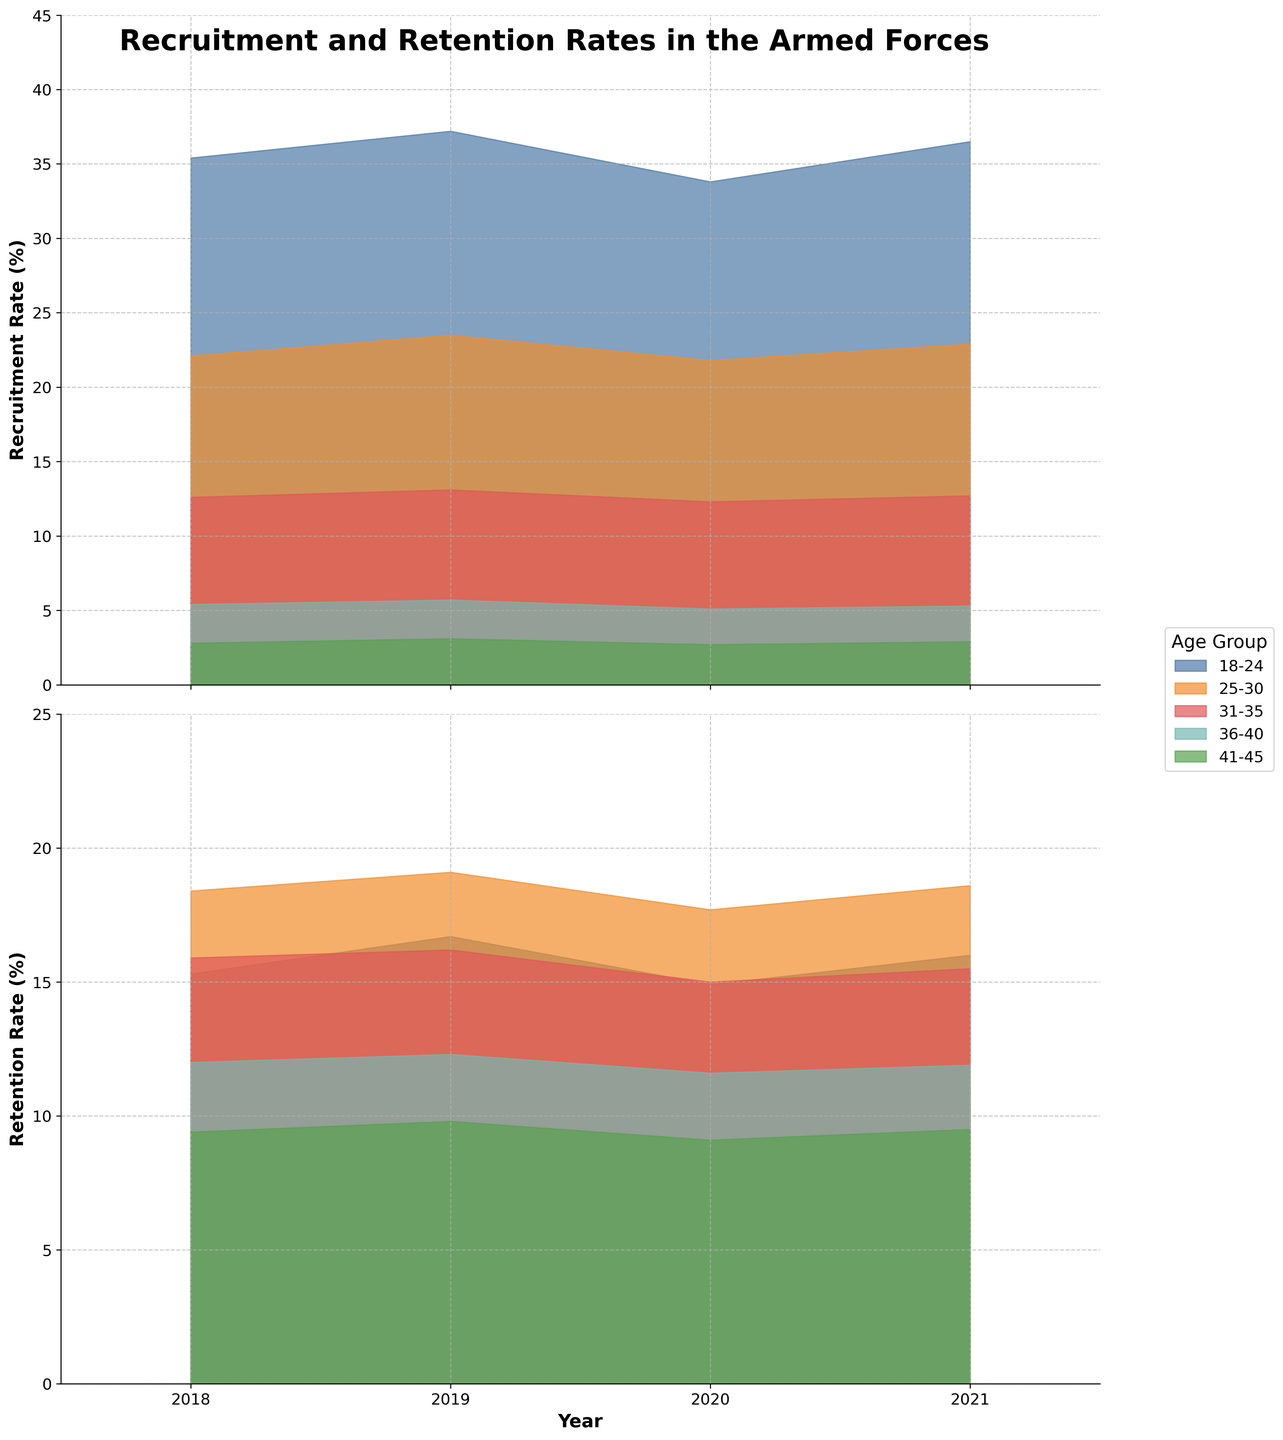What is the recruitment rate for the 25-30 age group in 2019? Look at the first plot and find the 25-30 age group's area curve for the year 2019.
Answer: 23.5 What is the trend in recruitment rates for the 18-24 age group from 2018 to 2021? In the first plot, observe the area representing the 18-24 age group from 2018 to 2021. The trend shows an increase from 2018 to 2019, a drop in 2020, and an increase again by 2021.
Answer: Increasing, decreasing, increasing Which age group has the highest recruitment rate in 2021? In the first plot, study the heights of the areas for different age groups in 2021. The 18-24 age group has the tallest section.
Answer: 18-24 Compare the retention rates of the 31-35 and 36-40 age groups in 2019. In the second plot, find the heights of the areas for the 31-35 and 36-40 age groups in 2019. The 31-35 age group has a retention rate of 16.2%, while the 36-40 age group has 12.3%.
Answer: 31-35 has higher retention What is the difference between the highest and lowest recruitment rates for any age group in 2021? In the first plot, identify the highest and lowest points for 2021. The 18-24 age group has the highest recruitment rate at 36.5%, and the 41-45 age group has the lowest at 2.9%. Subtract 2.9 from 36.5.
Answer: 33.6 Which age group's retention rate increased every year from 2018 to 2021? Examine the second plot and look for an area that consistently increases from 2018 to 2021. The retention rate of the 25-30 age group shows a steady increase.
Answer: 25-30 What is the average recruitment rate for the 18-24 age group over the four years? Add the recruitment rates for the 18-24 age group (35.4, 37.2, 33.8, 36.5) and divide by 4.
Answer: 35.725 How does the recruitment rate of the 36-40 age group in 2020 compare to its rate in 2018? In the first plot, compare the height of the 36-40 age group's area in 2020 to 2018. It decreased from 5.4% in 2018 to 5.1% in 2020.
Answer: Decreased Which age group had the smallest change in recruitment rate from 2018 to 2021? In the first plot, identify the age group with the least variation in height. The 31-35 age group had almost similar recruitment rates (12.6% in 2018 and 12.7% in 2021).
Answer: 31-35 What is the retention rate for the 41-45 age group in 2021, and how does it compare with its lowest retention rate over the period? In the second plot, find the retention rate for 41-45 in 2021 (9.5%). Identify its lowest rate during the period, which is 9.1% in 2020. Compare them: 9.5% is slightly higher than 9.1%.
Answer: 9.5%, slightly higher 